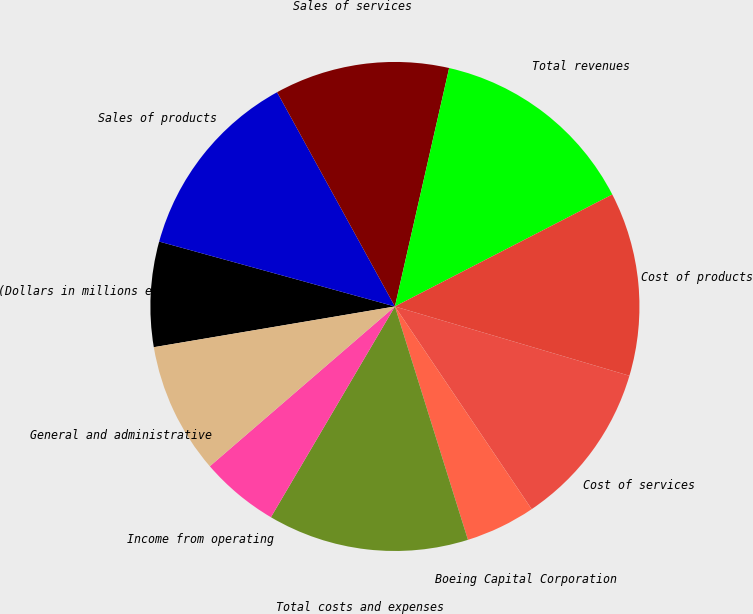<chart> <loc_0><loc_0><loc_500><loc_500><pie_chart><fcel>(Dollars in millions except<fcel>Sales of products<fcel>Sales of services<fcel>Total revenues<fcel>Cost of products<fcel>Cost of services<fcel>Boeing Capital Corporation<fcel>Total costs and expenses<fcel>Income from operating<fcel>General and administrative<nl><fcel>6.94%<fcel>12.72%<fcel>11.56%<fcel>13.87%<fcel>12.14%<fcel>10.98%<fcel>4.62%<fcel>13.29%<fcel>5.2%<fcel>8.67%<nl></chart> 